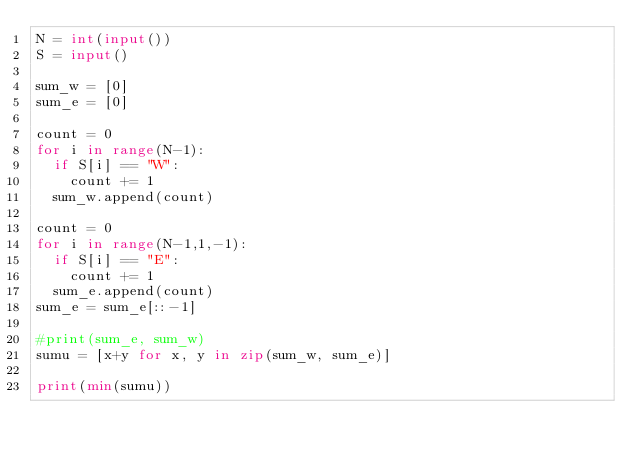Convert code to text. <code><loc_0><loc_0><loc_500><loc_500><_Python_>N = int(input())
S = input()

sum_w = [0]
sum_e = [0]

count = 0
for i in range(N-1):
  if S[i] == "W":
    count += 1
  sum_w.append(count)

count = 0
for i in range(N-1,1,-1):
  if S[i] == "E": 
    count += 1
  sum_e.append(count)
sum_e = sum_e[::-1]

#print(sum_e, sum_w)
sumu = [x+y for x, y in zip(sum_w, sum_e)]

print(min(sumu))</code> 